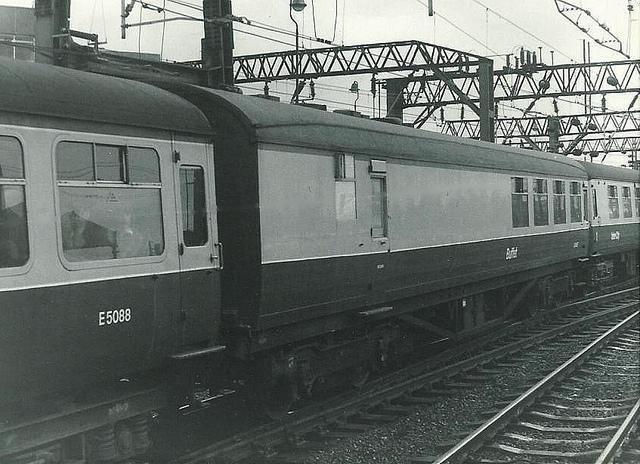How many skateboard wheels are visible?
Give a very brief answer. 0. 